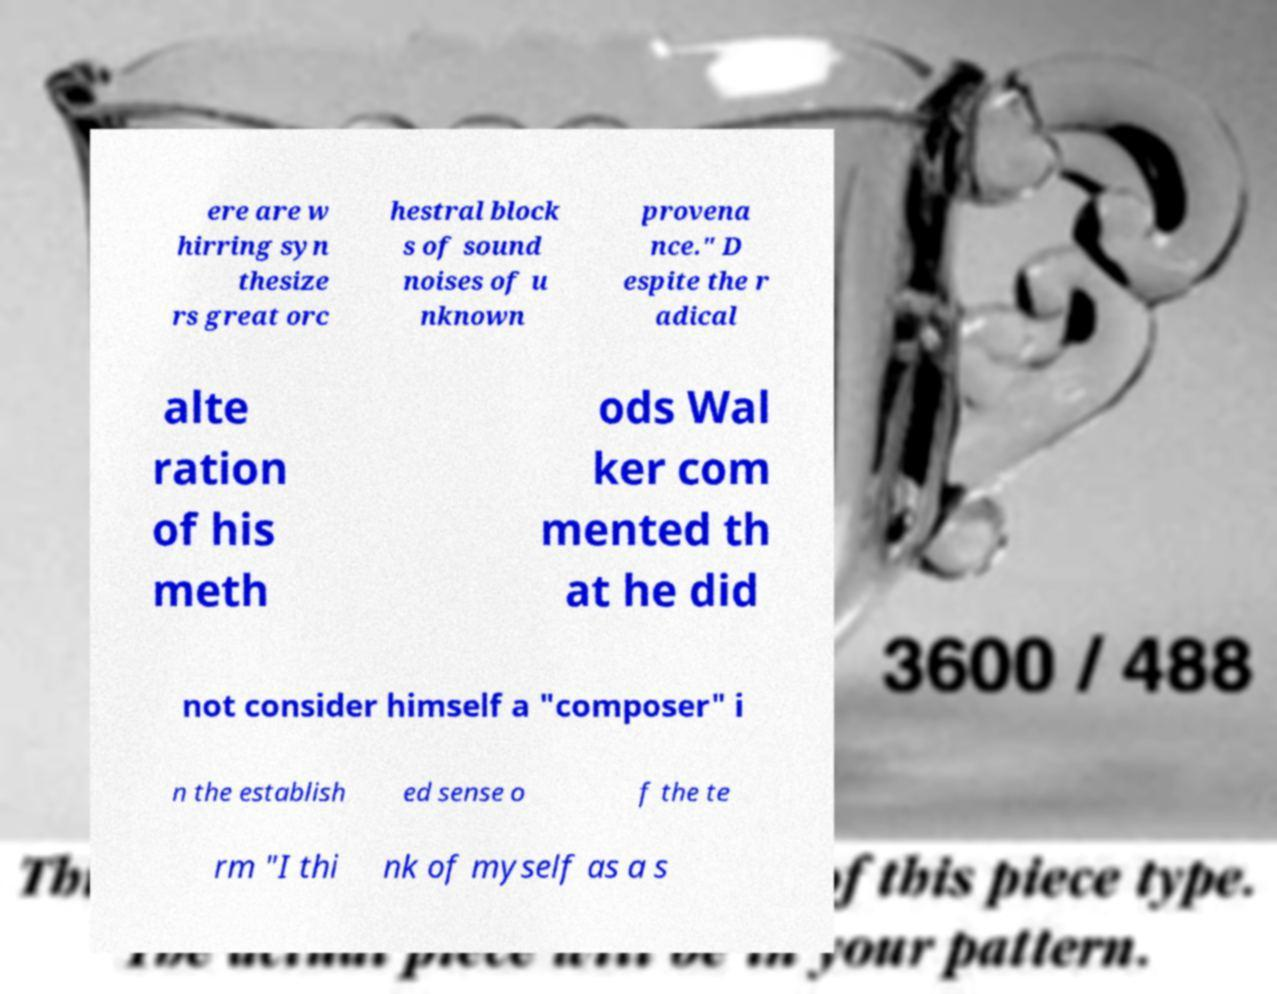For documentation purposes, I need the text within this image transcribed. Could you provide that? ere are w hirring syn thesize rs great orc hestral block s of sound noises of u nknown provena nce." D espite the r adical alte ration of his meth ods Wal ker com mented th at he did not consider himself a "composer" i n the establish ed sense o f the te rm "I thi nk of myself as a s 